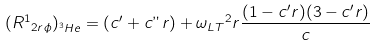<formula> <loc_0><loc_0><loc_500><loc_500>( { R ^ { 1 } } _ { 2 r { \phi } } ) _ { ^ { 3 } H e } = ( c ^ { \prime } + c " r ) + { { \omega } _ { L T } } ^ { 2 } r \frac { ( 1 - c ^ { \prime } r ) ( 3 - c ^ { \prime } r ) } { c }</formula> 